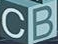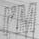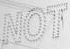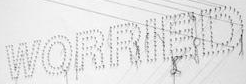Read the text from these images in sequence, separated by a semicolon. CB; I'M; NOT; WORRIED 